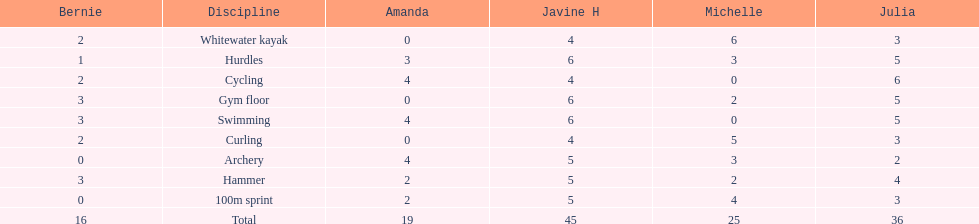Who scored the least on whitewater kayak? Amanda. 